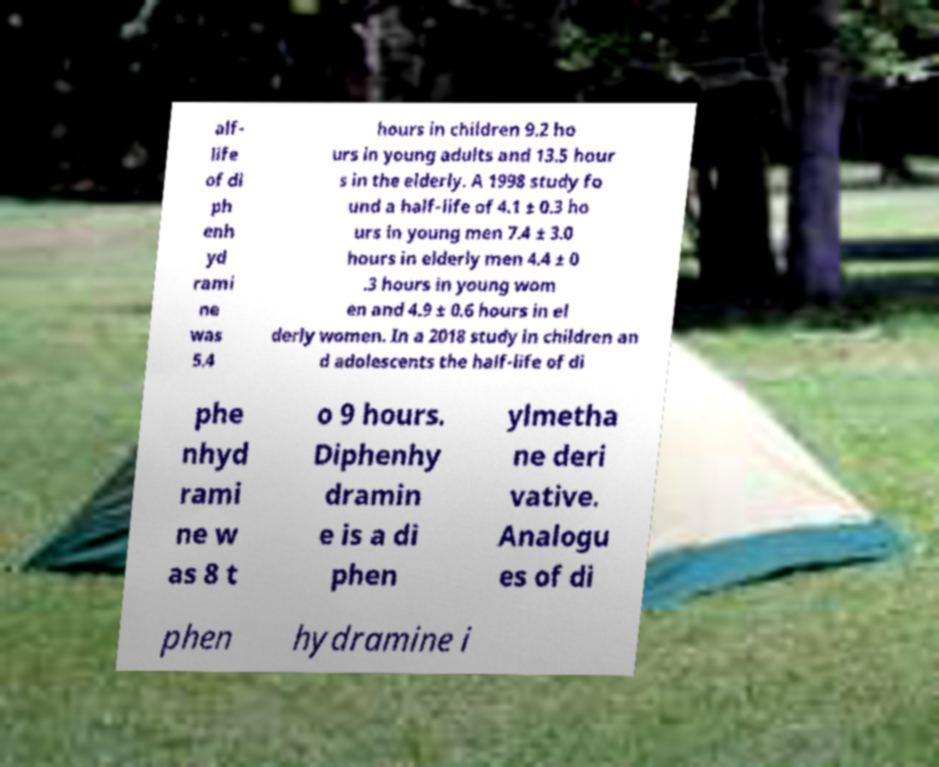What messages or text are displayed in this image? I need them in a readable, typed format. alf- life of di ph enh yd rami ne was 5.4 hours in children 9.2 ho urs in young adults and 13.5 hour s in the elderly. A 1998 study fo und a half-life of 4.1 ± 0.3 ho urs in young men 7.4 ± 3.0 hours in elderly men 4.4 ± 0 .3 hours in young wom en and 4.9 ± 0.6 hours in el derly women. In a 2018 study in children an d adolescents the half-life of di phe nhyd rami ne w as 8 t o 9 hours. Diphenhy dramin e is a di phen ylmetha ne deri vative. Analogu es of di phen hydramine i 